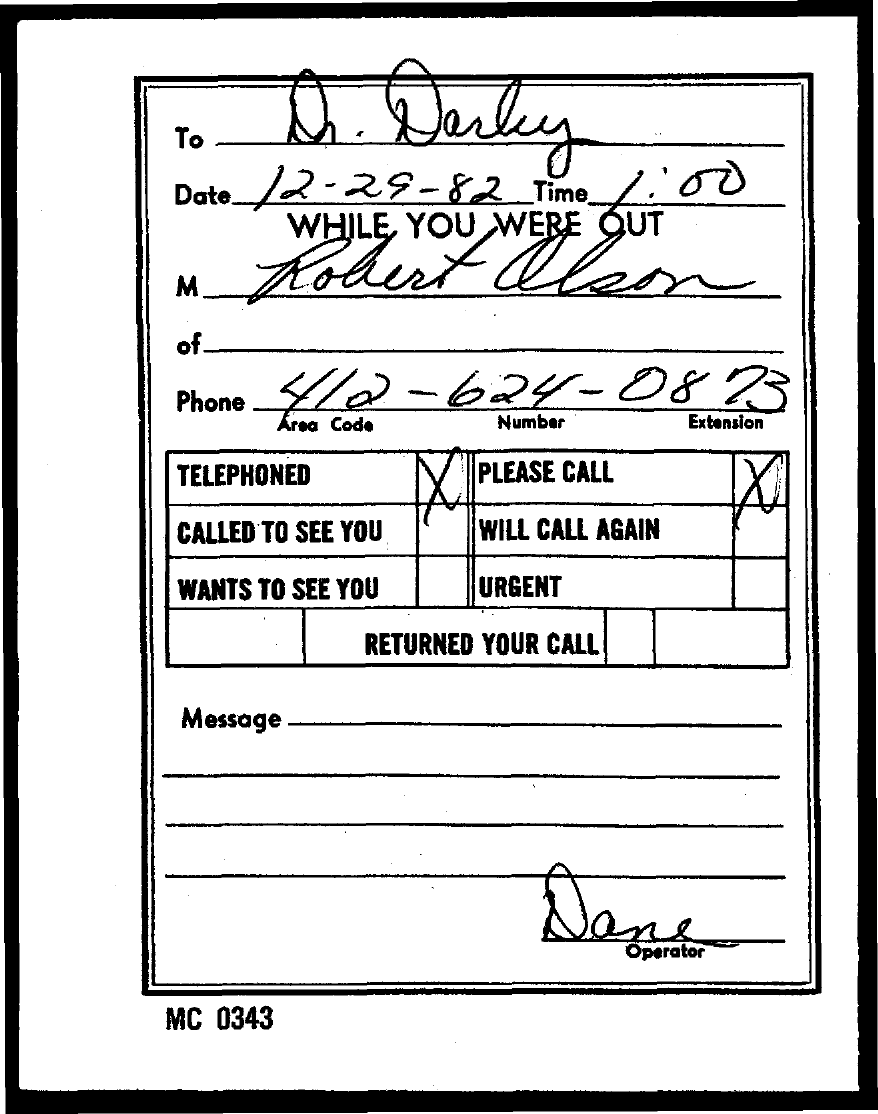Specify some key components in this picture. December 29, 1982, is the date in question. The phone number is 412-624-0873. The operator is Dane. The letter is addressed to Dr. Darby. The time is currently 1:00. 